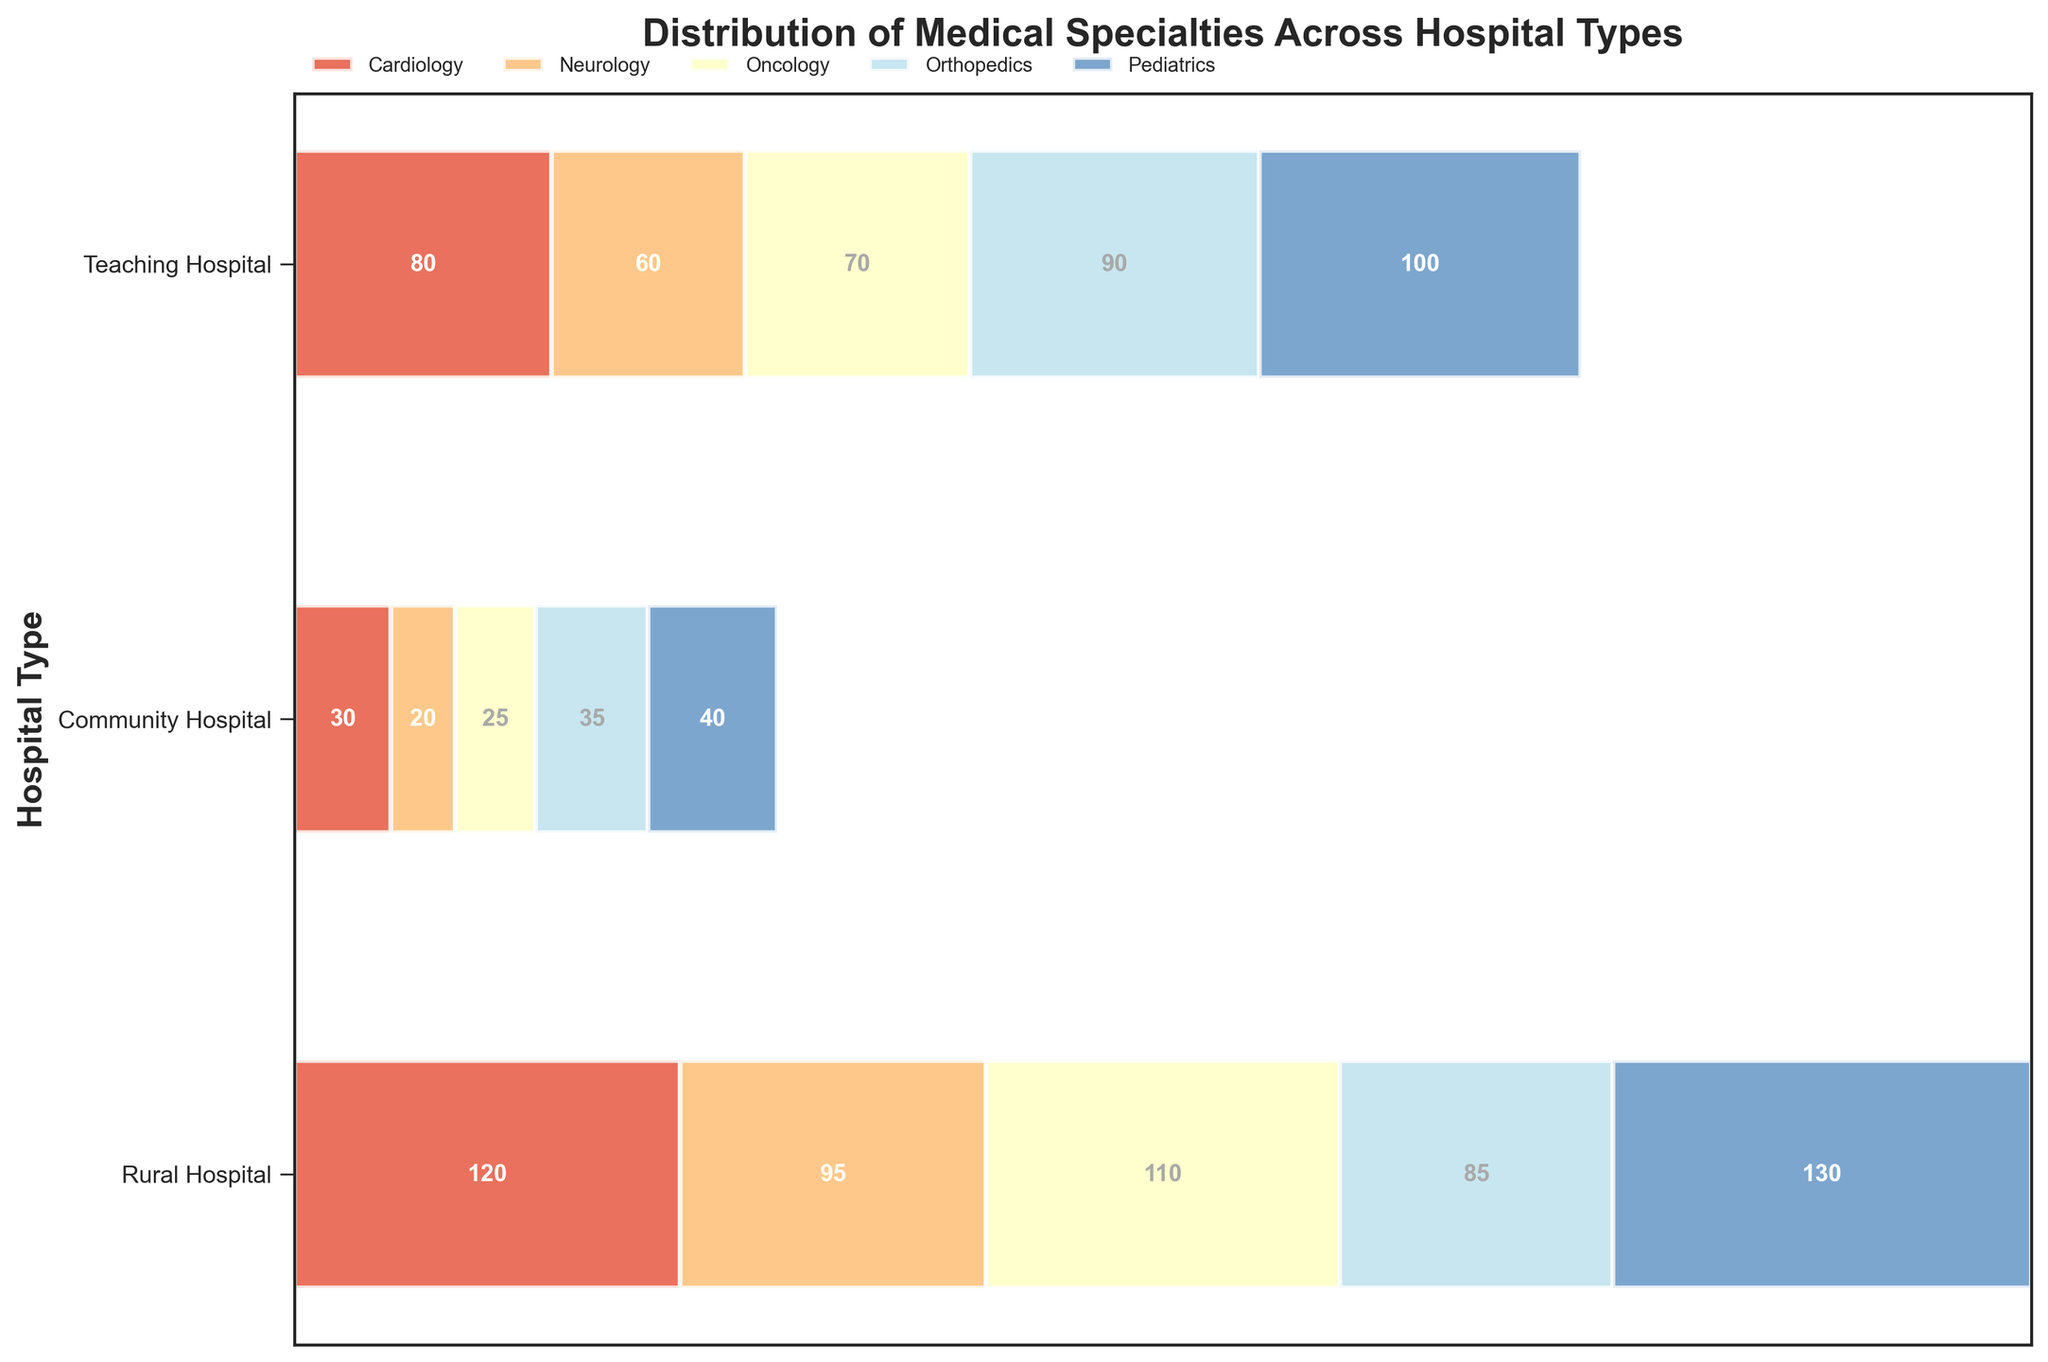What is the title of the plot? The title is located at the top of the plot and is written in bold font.
Answer: Distribution of Medical Specialties Across Hospital Types How many hospital types are represented in the plot? The plot has three distinct sections on the y-axis, each representing a hospital type, which can be identified from the labels on the left side of the plot.
Answer: Three Which medical specialty has the highest count in Teaching Hospitals? By observing the largest segment in the Teaching Hospitals section, which stretches furthest to the right, you can identify the specialty with the highest count.
Answer: Pediatrics The Cardiology count is higher in which hospital type, Community or Rural? Compare the width of the Cardiology segments in both Community Hospitals and Rural Hospitals. The wider segment indicates a higher count.
Answer: Community What is the combined count for Neurology and Orthopedics in Rural Hospitals? Find the Neurology and Orthopedics segments in the Rural Hospitals section and add their counts together: 20 (Neurology) + 35 (Orthopedics).
Answer: 55 Which hospital type has the lowest count for Oncology? Look for the smallest Oncology segment among the three hospital types. This segment will be the thinnest.
Answer: Rural How does the distribution of Pediatrics compare between Teaching Hospitals and Community Hospitals? Compare the width of the Pediatrics segments in Teaching and Community Hospitals. Teaching Hospitals have a wider segment for Pediatrics, indicating a higher count.
Answer: Higher in Teaching Hospitals What is the total count of medical specialties in Community Hospitals? Sum up the counts of all medical specialties in Community Hospitals: 80 (Cardiology) + 60 (Neurology) + 70 (Oncology) + 90 (Orthopedics) + 100 (Pediatrics).
Answer: 400 Which specialty has the most uniform distribution across all hospital types? Look for the specialty with similar segment widths across all three hospital types. Notice that Orthopedics does not have extreme differences in segment widths.
Answer: Orthopedics If a new Rural Hospital is added with the same distribution of specialties, what would be the new count for Pediatrics in Rural Hospitals? Currently, Rural Hospitals have 40 Pediatrics. Adding another hospital with the same distribution means doubling this specialty count: 40 * 2.
Answer: 80 